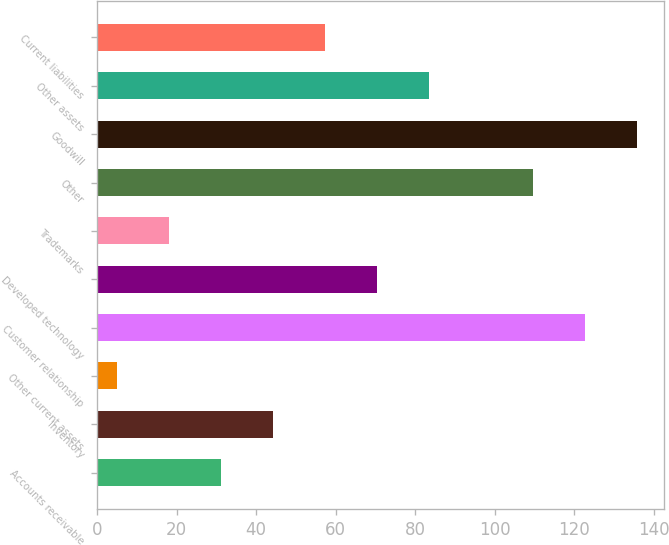Convert chart to OTSL. <chart><loc_0><loc_0><loc_500><loc_500><bar_chart><fcel>Accounts receivable<fcel>Inventory<fcel>Other current assets<fcel>Customer relationship<fcel>Developed technology<fcel>Trademarks<fcel>Other<fcel>Goodwill<fcel>Other assets<fcel>Current liabilities<nl><fcel>31.14<fcel>44.21<fcel>5<fcel>122.63<fcel>70.35<fcel>18.07<fcel>109.56<fcel>135.7<fcel>83.42<fcel>57.28<nl></chart> 